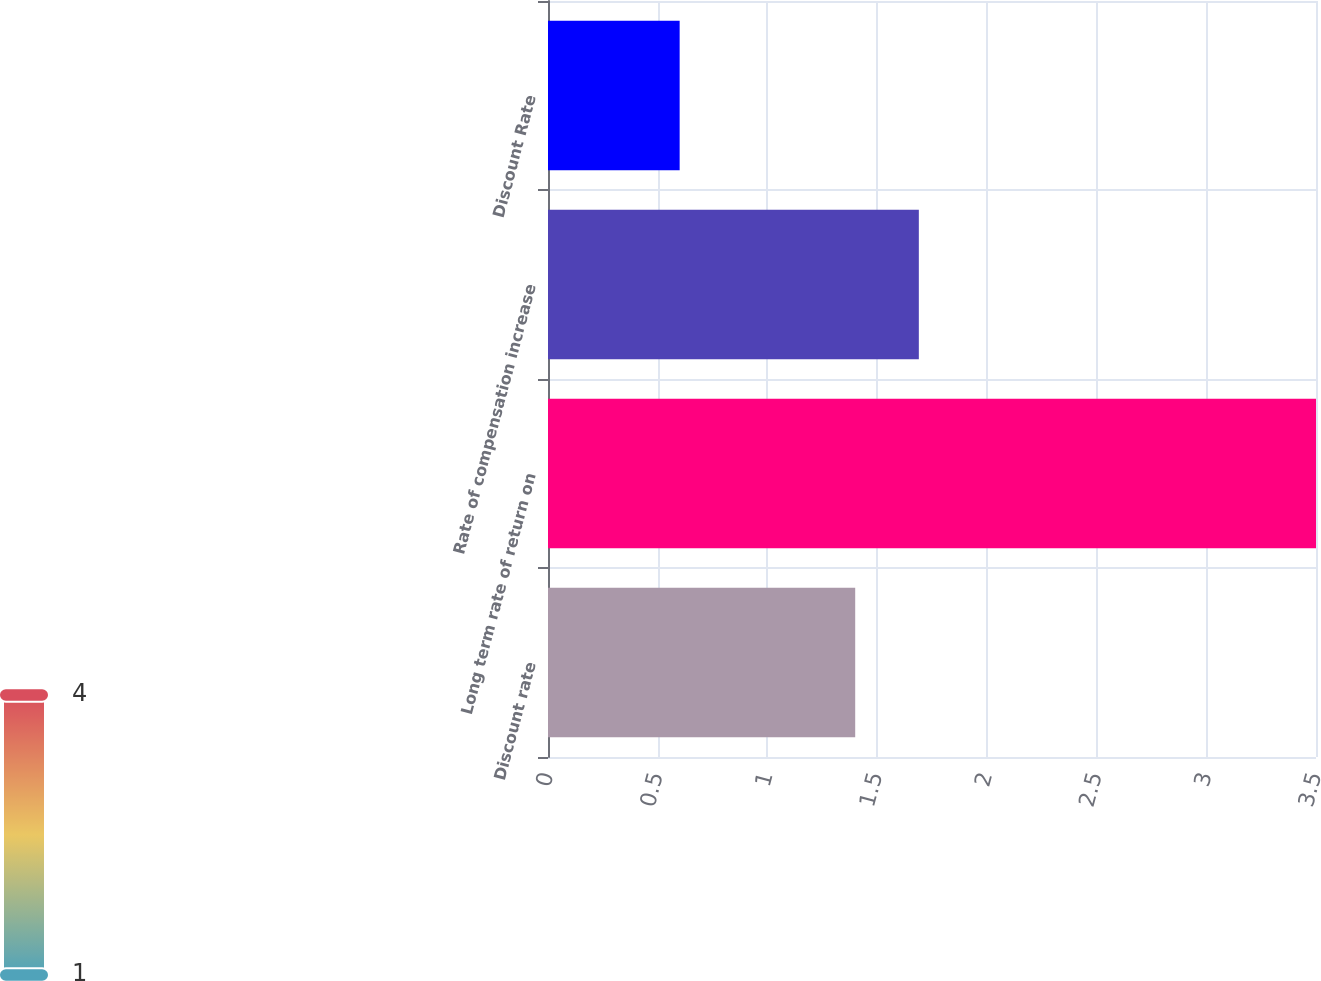<chart> <loc_0><loc_0><loc_500><loc_500><bar_chart><fcel>Discount rate<fcel>Long term rate of return on<fcel>Rate of compensation increase<fcel>Discount Rate<nl><fcel>1.4<fcel>3.5<fcel>1.69<fcel>0.6<nl></chart> 